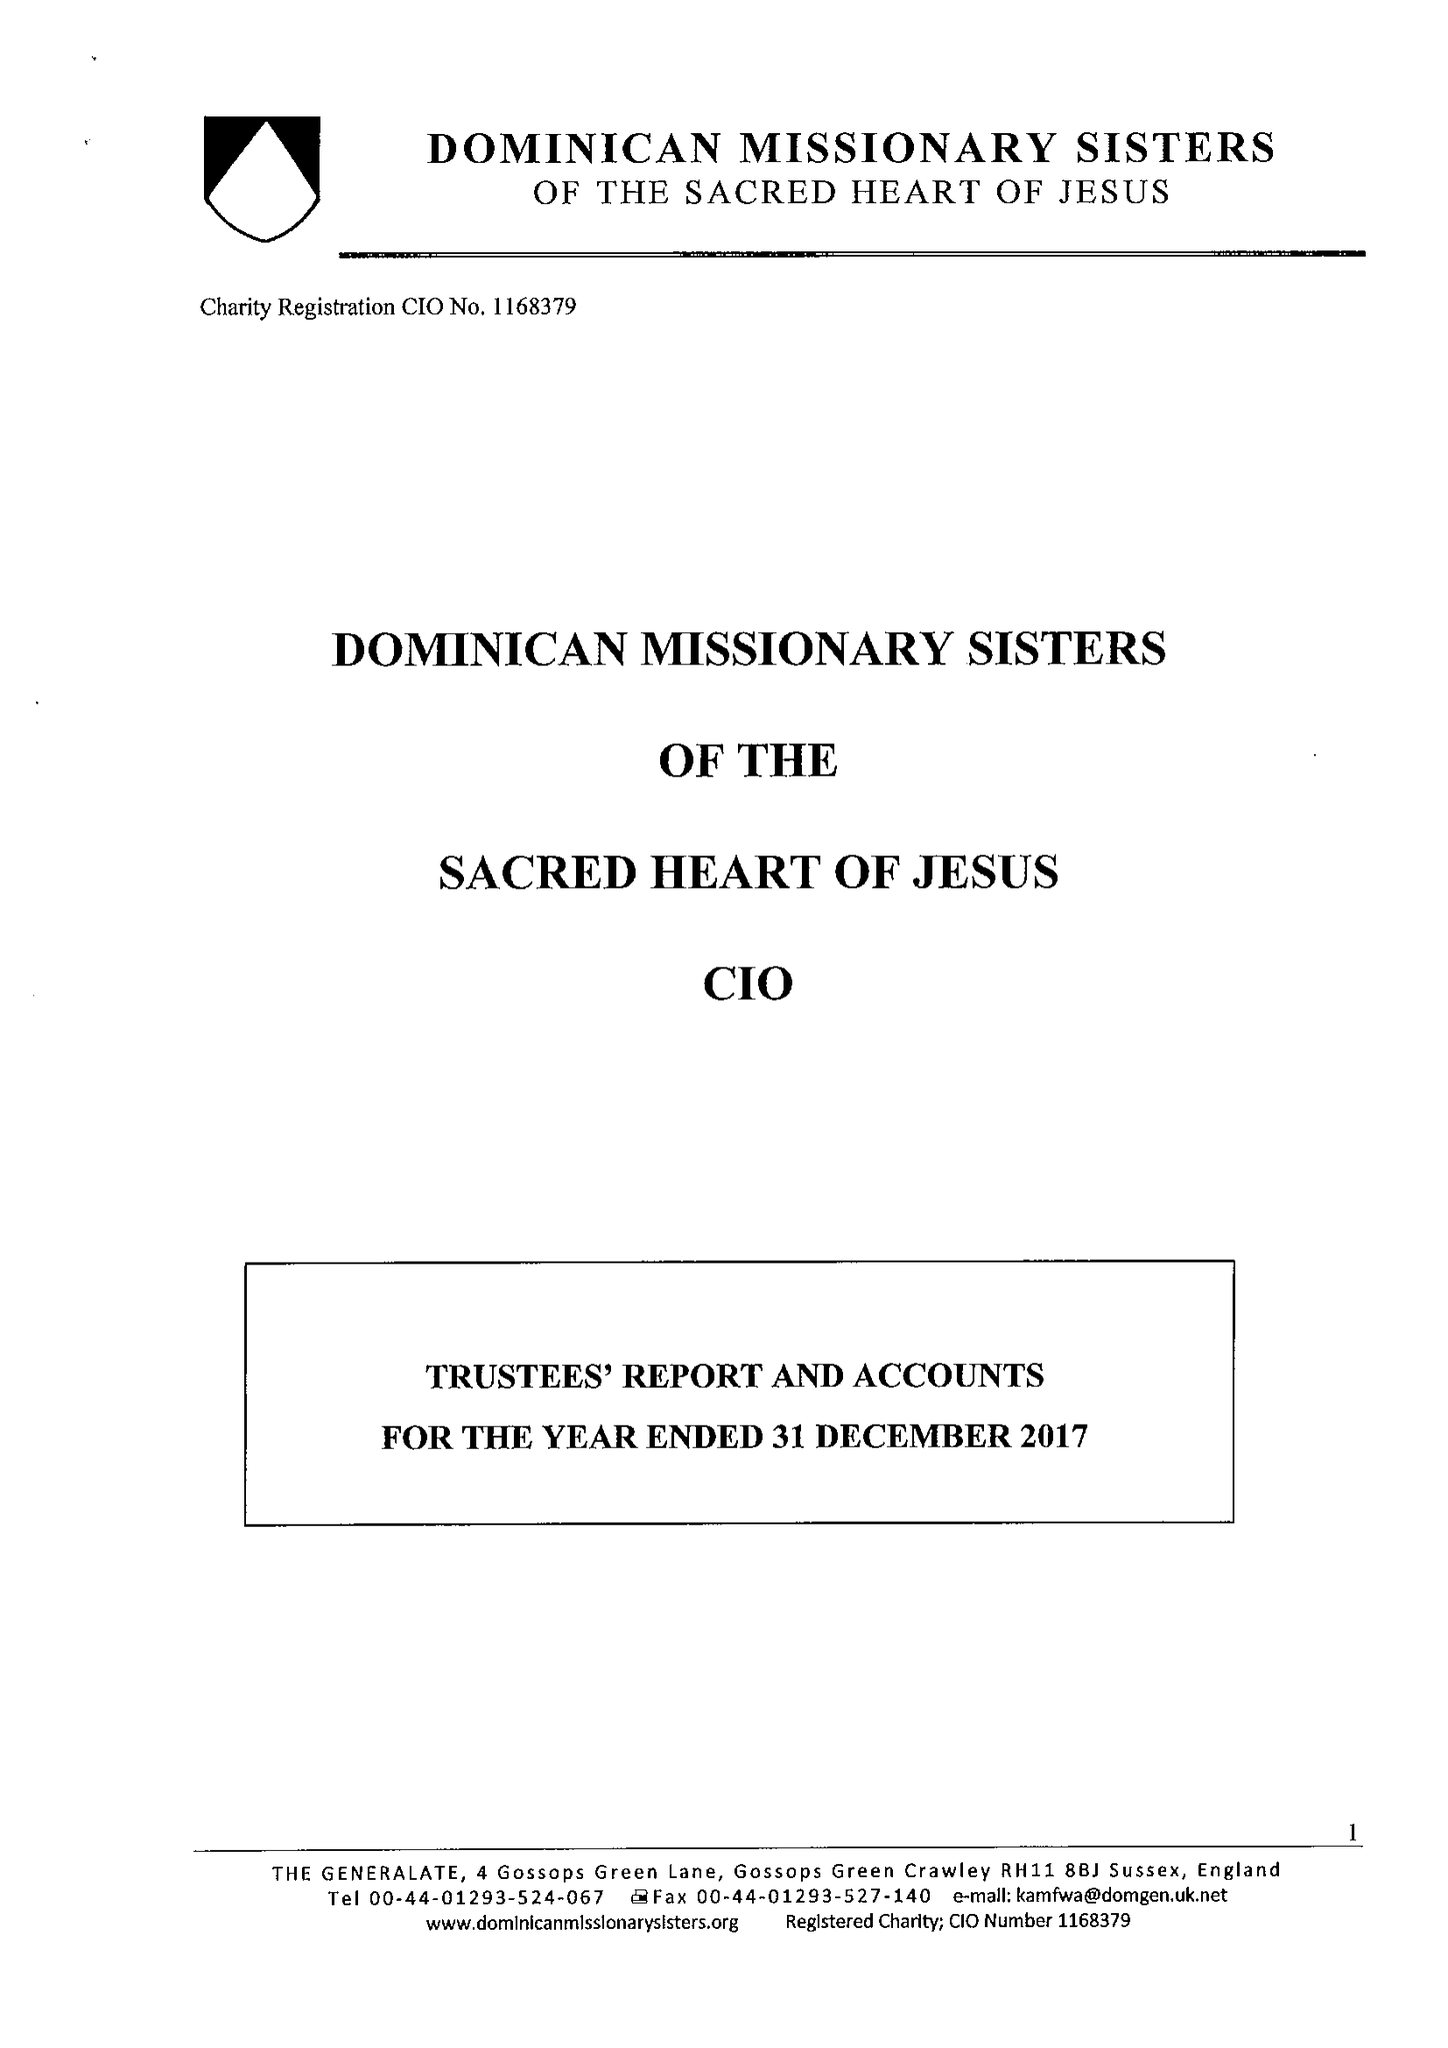What is the value for the address__street_line?
Answer the question using a single word or phrase. 4 GOSSOPS GREEN LANE 